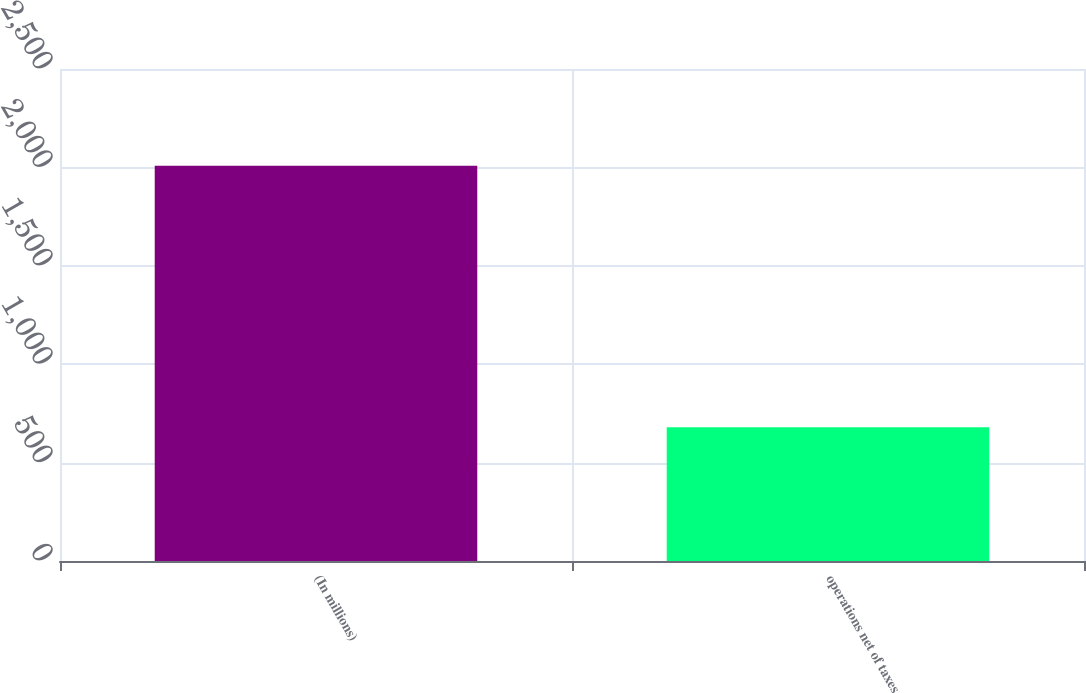<chart> <loc_0><loc_0><loc_500><loc_500><bar_chart><fcel>(In millions)<fcel>operations net of taxes<nl><fcel>2008<fcel>679<nl></chart> 